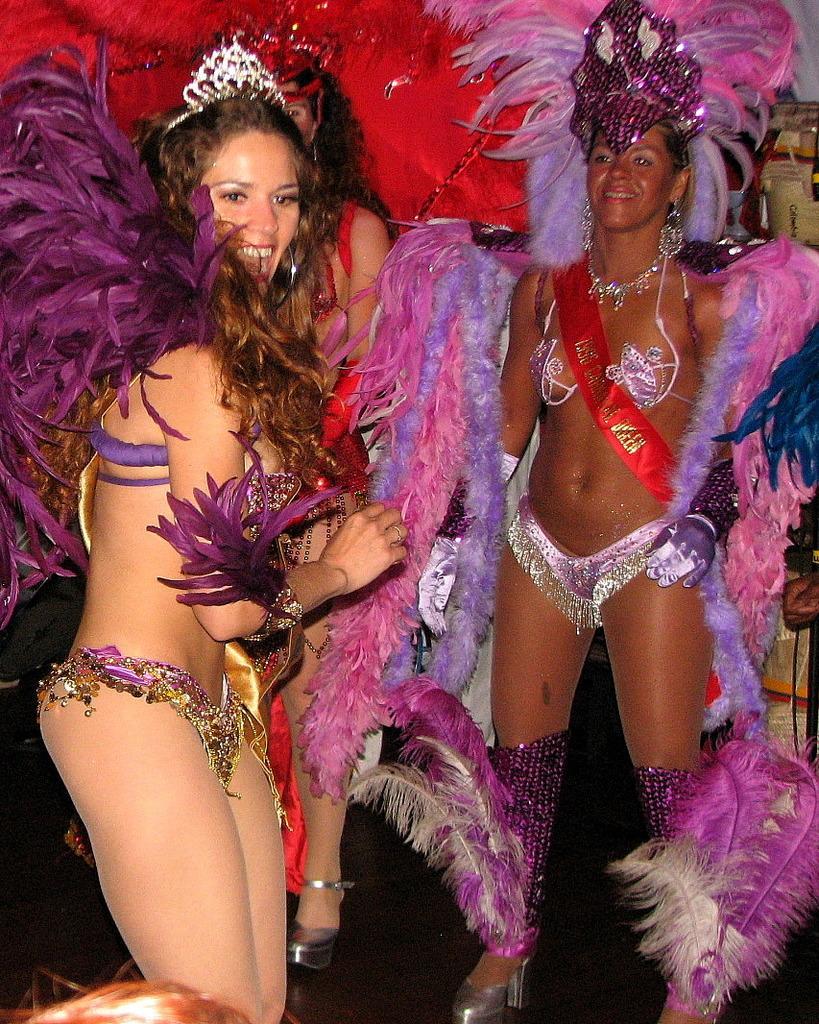In one or two sentences, can you explain what this image depicts? In this image there are three persons in fancy dresses are standing, they are decorated with feathers. 